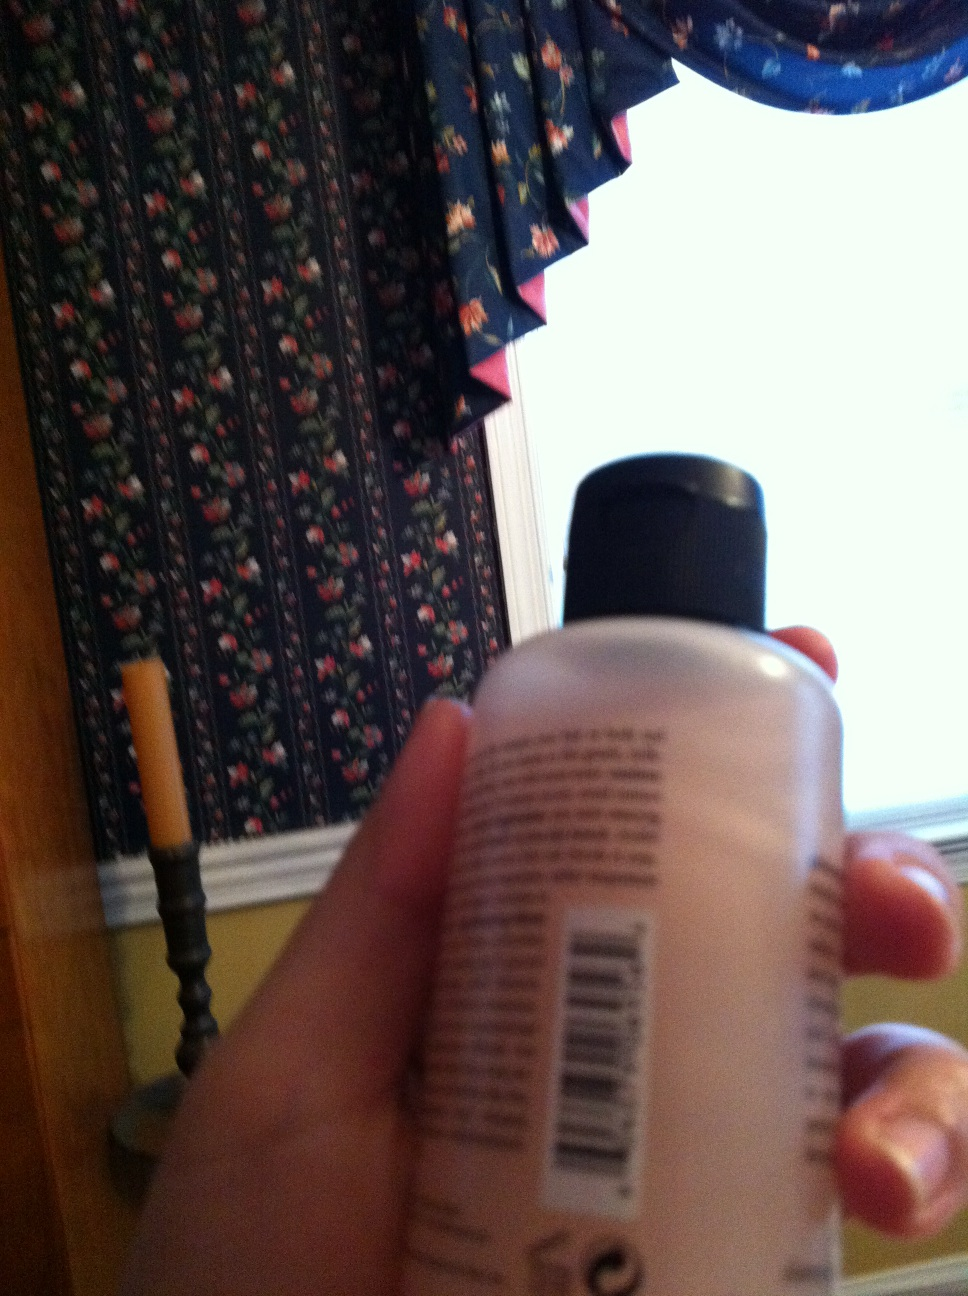What do you think is written on the bottle? The bottle likely contains some form of skin care or personal hygiene product based on common shapes and labels of similar items. The blurry text on it might include information such as the product's brand name, its ingredients, usage instructions, and possibly a barcode. 